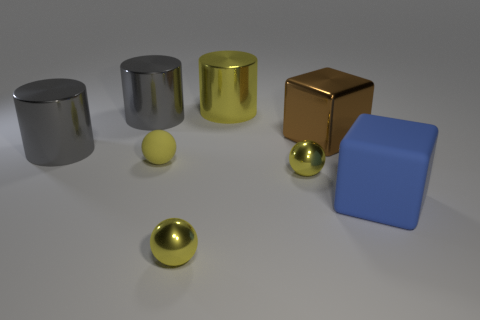Subtract all yellow spheres. How many were subtracted if there are1yellow spheres left? 2 Subtract all yellow metal cylinders. How many cylinders are left? 2 Subtract all spheres. How many objects are left? 5 Subtract 2 cylinders. How many cylinders are left? 1 Subtract all yellow cylinders. How many cylinders are left? 2 Add 1 brown things. How many objects exist? 9 Subtract all green cylinders. Subtract all purple cubes. How many cylinders are left? 3 Subtract all cyan cylinders. How many cyan balls are left? 0 Subtract all small yellow metal spheres. Subtract all blue rubber blocks. How many objects are left? 5 Add 1 yellow metal cylinders. How many yellow metal cylinders are left? 2 